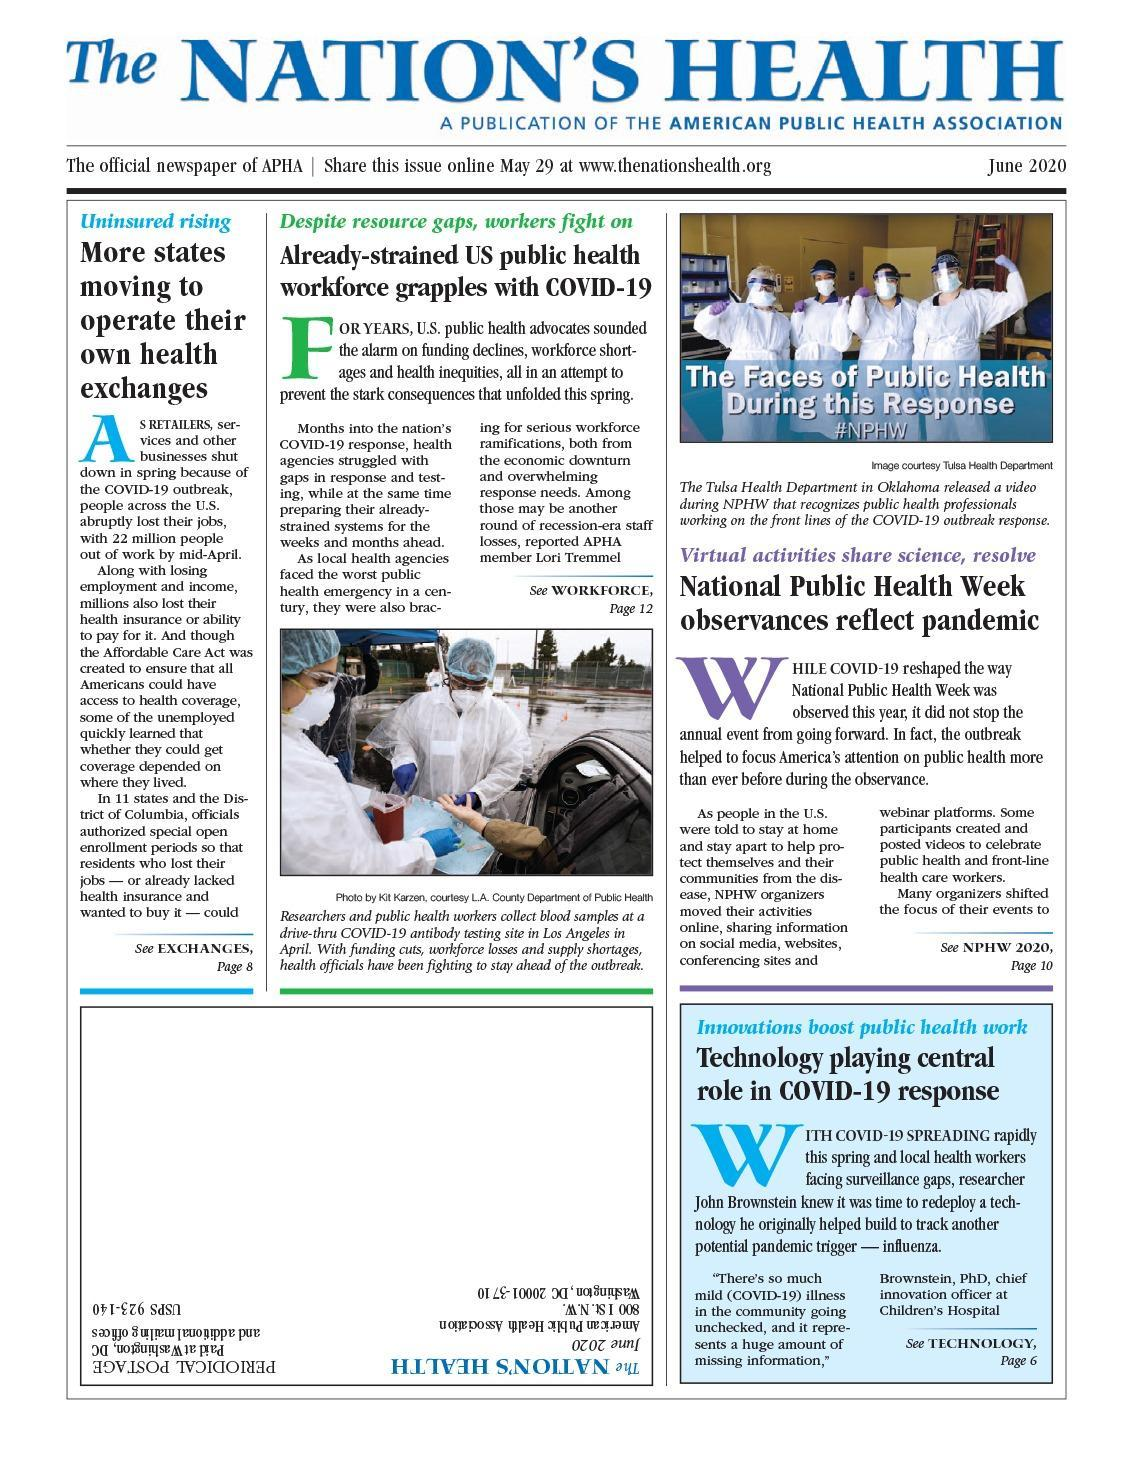What was created to ensure health coverage access to all Americans?
Answer the question with a short phrase. Affordable Care Act Lori Tremmel is a member of which association? APHA What was being collected at drive-thru COVID-19 testing site shown in the photo? blood samples How many people are shown in the photo at the top of the infographic? 4 The observance of which event was shifted online due to the pandemic situation? NPHW How many people across the US were out of work by mid-April? 22 million What is the color of the protective covering worn by all the health workers in the photos - green, blue or white? white 